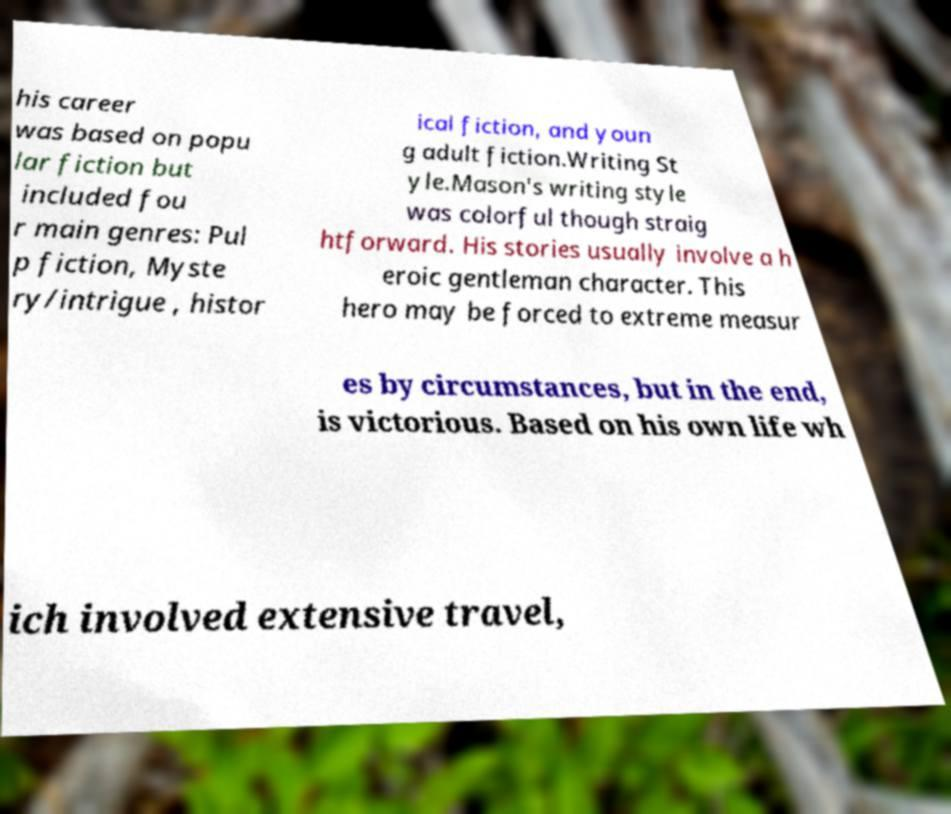There's text embedded in this image that I need extracted. Can you transcribe it verbatim? his career was based on popu lar fiction but included fou r main genres: Pul p fiction, Myste ry/intrigue , histor ical fiction, and youn g adult fiction.Writing St yle.Mason's writing style was colorful though straig htforward. His stories usually involve a h eroic gentleman character. This hero may be forced to extreme measur es by circumstances, but in the end, is victorious. Based on his own life wh ich involved extensive travel, 